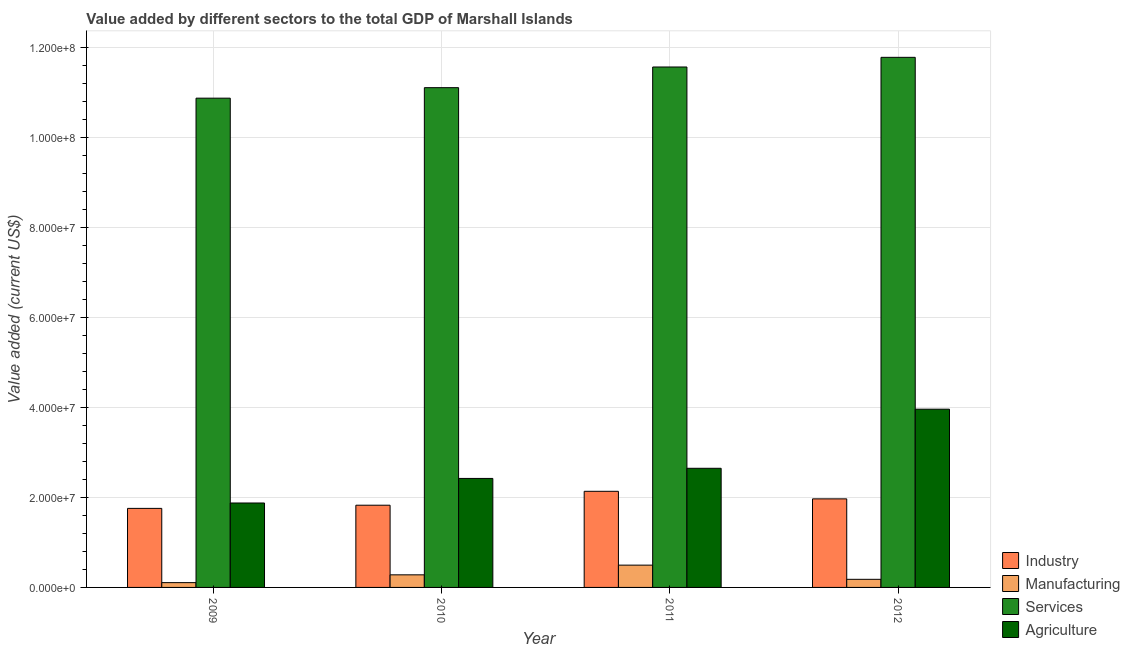Are the number of bars per tick equal to the number of legend labels?
Make the answer very short. Yes. Are the number of bars on each tick of the X-axis equal?
Provide a succinct answer. Yes. How many bars are there on the 4th tick from the left?
Make the answer very short. 4. What is the label of the 4th group of bars from the left?
Your answer should be compact. 2012. What is the value added by services sector in 2012?
Your answer should be very brief. 1.18e+08. Across all years, what is the maximum value added by agricultural sector?
Ensure brevity in your answer.  3.96e+07. Across all years, what is the minimum value added by manufacturing sector?
Give a very brief answer. 1.06e+06. In which year was the value added by manufacturing sector maximum?
Ensure brevity in your answer.  2011. What is the total value added by industrial sector in the graph?
Your answer should be compact. 7.68e+07. What is the difference between the value added by industrial sector in 2010 and that in 2011?
Offer a terse response. -3.09e+06. What is the difference between the value added by agricultural sector in 2009 and the value added by services sector in 2012?
Keep it short and to the point. -2.08e+07. What is the average value added by services sector per year?
Your response must be concise. 1.13e+08. In the year 2009, what is the difference between the value added by manufacturing sector and value added by industrial sector?
Your answer should be very brief. 0. In how many years, is the value added by agricultural sector greater than 64000000 US$?
Keep it short and to the point. 0. What is the ratio of the value added by services sector in 2010 to that in 2012?
Ensure brevity in your answer.  0.94. What is the difference between the highest and the second highest value added by industrial sector?
Provide a succinct answer. 1.68e+06. What is the difference between the highest and the lowest value added by manufacturing sector?
Your response must be concise. 3.89e+06. In how many years, is the value added by industrial sector greater than the average value added by industrial sector taken over all years?
Make the answer very short. 2. What does the 2nd bar from the left in 2012 represents?
Provide a short and direct response. Manufacturing. What does the 2nd bar from the right in 2011 represents?
Provide a short and direct response. Services. How many years are there in the graph?
Your answer should be very brief. 4. Does the graph contain grids?
Your answer should be very brief. Yes. How many legend labels are there?
Provide a short and direct response. 4. What is the title of the graph?
Provide a short and direct response. Value added by different sectors to the total GDP of Marshall Islands. What is the label or title of the Y-axis?
Your response must be concise. Value added (current US$). What is the Value added (current US$) in Industry in 2009?
Offer a very short reply. 1.76e+07. What is the Value added (current US$) in Manufacturing in 2009?
Your answer should be very brief. 1.06e+06. What is the Value added (current US$) of Services in 2009?
Provide a short and direct response. 1.09e+08. What is the Value added (current US$) of Agriculture in 2009?
Ensure brevity in your answer.  1.87e+07. What is the Value added (current US$) in Industry in 2010?
Offer a very short reply. 1.83e+07. What is the Value added (current US$) of Manufacturing in 2010?
Provide a short and direct response. 2.80e+06. What is the Value added (current US$) in Services in 2010?
Ensure brevity in your answer.  1.11e+08. What is the Value added (current US$) of Agriculture in 2010?
Your answer should be compact. 2.42e+07. What is the Value added (current US$) in Industry in 2011?
Offer a very short reply. 2.13e+07. What is the Value added (current US$) of Manufacturing in 2011?
Offer a terse response. 4.95e+06. What is the Value added (current US$) of Services in 2011?
Provide a short and direct response. 1.16e+08. What is the Value added (current US$) in Agriculture in 2011?
Make the answer very short. 2.65e+07. What is the Value added (current US$) in Industry in 2012?
Offer a very short reply. 1.97e+07. What is the Value added (current US$) of Manufacturing in 2012?
Your answer should be very brief. 1.80e+06. What is the Value added (current US$) of Services in 2012?
Provide a short and direct response. 1.18e+08. What is the Value added (current US$) of Agriculture in 2012?
Make the answer very short. 3.96e+07. Across all years, what is the maximum Value added (current US$) of Industry?
Provide a short and direct response. 2.13e+07. Across all years, what is the maximum Value added (current US$) in Manufacturing?
Offer a terse response. 4.95e+06. Across all years, what is the maximum Value added (current US$) in Services?
Your answer should be compact. 1.18e+08. Across all years, what is the maximum Value added (current US$) in Agriculture?
Offer a terse response. 3.96e+07. Across all years, what is the minimum Value added (current US$) of Industry?
Ensure brevity in your answer.  1.76e+07. Across all years, what is the minimum Value added (current US$) in Manufacturing?
Your response must be concise. 1.06e+06. Across all years, what is the minimum Value added (current US$) in Services?
Your answer should be compact. 1.09e+08. Across all years, what is the minimum Value added (current US$) in Agriculture?
Your answer should be compact. 1.87e+07. What is the total Value added (current US$) of Industry in the graph?
Your answer should be very brief. 7.68e+07. What is the total Value added (current US$) in Manufacturing in the graph?
Your answer should be very brief. 1.06e+07. What is the total Value added (current US$) of Services in the graph?
Give a very brief answer. 4.53e+08. What is the total Value added (current US$) in Agriculture in the graph?
Keep it short and to the point. 1.09e+08. What is the difference between the Value added (current US$) in Industry in 2009 and that in 2010?
Offer a very short reply. -7.02e+05. What is the difference between the Value added (current US$) in Manufacturing in 2009 and that in 2010?
Keep it short and to the point. -1.73e+06. What is the difference between the Value added (current US$) of Services in 2009 and that in 2010?
Your response must be concise. -2.33e+06. What is the difference between the Value added (current US$) of Agriculture in 2009 and that in 2010?
Your answer should be very brief. -5.46e+06. What is the difference between the Value added (current US$) in Industry in 2009 and that in 2011?
Ensure brevity in your answer.  -3.79e+06. What is the difference between the Value added (current US$) in Manufacturing in 2009 and that in 2011?
Offer a terse response. -3.89e+06. What is the difference between the Value added (current US$) of Services in 2009 and that in 2011?
Your response must be concise. -6.92e+06. What is the difference between the Value added (current US$) of Agriculture in 2009 and that in 2011?
Ensure brevity in your answer.  -7.71e+06. What is the difference between the Value added (current US$) of Industry in 2009 and that in 2012?
Offer a terse response. -2.11e+06. What is the difference between the Value added (current US$) of Manufacturing in 2009 and that in 2012?
Offer a very short reply. -7.34e+05. What is the difference between the Value added (current US$) in Services in 2009 and that in 2012?
Make the answer very short. -9.07e+06. What is the difference between the Value added (current US$) in Agriculture in 2009 and that in 2012?
Offer a very short reply. -2.08e+07. What is the difference between the Value added (current US$) in Industry in 2010 and that in 2011?
Offer a terse response. -3.09e+06. What is the difference between the Value added (current US$) of Manufacturing in 2010 and that in 2011?
Offer a very short reply. -2.16e+06. What is the difference between the Value added (current US$) in Services in 2010 and that in 2011?
Give a very brief answer. -4.59e+06. What is the difference between the Value added (current US$) of Agriculture in 2010 and that in 2011?
Your answer should be very brief. -2.25e+06. What is the difference between the Value added (current US$) in Industry in 2010 and that in 2012?
Offer a very short reply. -1.41e+06. What is the difference between the Value added (current US$) in Manufacturing in 2010 and that in 2012?
Your response must be concise. 9.96e+05. What is the difference between the Value added (current US$) of Services in 2010 and that in 2012?
Your response must be concise. -6.74e+06. What is the difference between the Value added (current US$) of Agriculture in 2010 and that in 2012?
Make the answer very short. -1.54e+07. What is the difference between the Value added (current US$) of Industry in 2011 and that in 2012?
Your answer should be very brief. 1.68e+06. What is the difference between the Value added (current US$) of Manufacturing in 2011 and that in 2012?
Your response must be concise. 3.15e+06. What is the difference between the Value added (current US$) of Services in 2011 and that in 2012?
Keep it short and to the point. -2.14e+06. What is the difference between the Value added (current US$) of Agriculture in 2011 and that in 2012?
Offer a terse response. -1.31e+07. What is the difference between the Value added (current US$) in Industry in 2009 and the Value added (current US$) in Manufacturing in 2010?
Make the answer very short. 1.48e+07. What is the difference between the Value added (current US$) in Industry in 2009 and the Value added (current US$) in Services in 2010?
Provide a short and direct response. -9.34e+07. What is the difference between the Value added (current US$) of Industry in 2009 and the Value added (current US$) of Agriculture in 2010?
Offer a terse response. -6.65e+06. What is the difference between the Value added (current US$) of Manufacturing in 2009 and the Value added (current US$) of Services in 2010?
Ensure brevity in your answer.  -1.10e+08. What is the difference between the Value added (current US$) in Manufacturing in 2009 and the Value added (current US$) in Agriculture in 2010?
Your answer should be very brief. -2.31e+07. What is the difference between the Value added (current US$) in Services in 2009 and the Value added (current US$) in Agriculture in 2010?
Ensure brevity in your answer.  8.44e+07. What is the difference between the Value added (current US$) of Industry in 2009 and the Value added (current US$) of Manufacturing in 2011?
Provide a short and direct response. 1.26e+07. What is the difference between the Value added (current US$) of Industry in 2009 and the Value added (current US$) of Services in 2011?
Your answer should be very brief. -9.80e+07. What is the difference between the Value added (current US$) of Industry in 2009 and the Value added (current US$) of Agriculture in 2011?
Your response must be concise. -8.90e+06. What is the difference between the Value added (current US$) in Manufacturing in 2009 and the Value added (current US$) in Services in 2011?
Give a very brief answer. -1.15e+08. What is the difference between the Value added (current US$) of Manufacturing in 2009 and the Value added (current US$) of Agriculture in 2011?
Your response must be concise. -2.54e+07. What is the difference between the Value added (current US$) in Services in 2009 and the Value added (current US$) in Agriculture in 2011?
Give a very brief answer. 8.22e+07. What is the difference between the Value added (current US$) of Industry in 2009 and the Value added (current US$) of Manufacturing in 2012?
Your answer should be very brief. 1.58e+07. What is the difference between the Value added (current US$) of Industry in 2009 and the Value added (current US$) of Services in 2012?
Keep it short and to the point. -1.00e+08. What is the difference between the Value added (current US$) of Industry in 2009 and the Value added (current US$) of Agriculture in 2012?
Provide a succinct answer. -2.20e+07. What is the difference between the Value added (current US$) in Manufacturing in 2009 and the Value added (current US$) in Services in 2012?
Your response must be concise. -1.17e+08. What is the difference between the Value added (current US$) of Manufacturing in 2009 and the Value added (current US$) of Agriculture in 2012?
Keep it short and to the point. -3.85e+07. What is the difference between the Value added (current US$) in Services in 2009 and the Value added (current US$) in Agriculture in 2012?
Offer a very short reply. 6.91e+07. What is the difference between the Value added (current US$) in Industry in 2010 and the Value added (current US$) in Manufacturing in 2011?
Your answer should be very brief. 1.33e+07. What is the difference between the Value added (current US$) in Industry in 2010 and the Value added (current US$) in Services in 2011?
Ensure brevity in your answer.  -9.73e+07. What is the difference between the Value added (current US$) of Industry in 2010 and the Value added (current US$) of Agriculture in 2011?
Keep it short and to the point. -8.20e+06. What is the difference between the Value added (current US$) of Manufacturing in 2010 and the Value added (current US$) of Services in 2011?
Offer a terse response. -1.13e+08. What is the difference between the Value added (current US$) of Manufacturing in 2010 and the Value added (current US$) of Agriculture in 2011?
Offer a terse response. -2.37e+07. What is the difference between the Value added (current US$) in Services in 2010 and the Value added (current US$) in Agriculture in 2011?
Your response must be concise. 8.45e+07. What is the difference between the Value added (current US$) in Industry in 2010 and the Value added (current US$) in Manufacturing in 2012?
Offer a very short reply. 1.65e+07. What is the difference between the Value added (current US$) of Industry in 2010 and the Value added (current US$) of Services in 2012?
Offer a terse response. -9.95e+07. What is the difference between the Value added (current US$) in Industry in 2010 and the Value added (current US$) in Agriculture in 2012?
Give a very brief answer. -2.13e+07. What is the difference between the Value added (current US$) in Manufacturing in 2010 and the Value added (current US$) in Services in 2012?
Provide a succinct answer. -1.15e+08. What is the difference between the Value added (current US$) of Manufacturing in 2010 and the Value added (current US$) of Agriculture in 2012?
Your response must be concise. -3.68e+07. What is the difference between the Value added (current US$) in Services in 2010 and the Value added (current US$) in Agriculture in 2012?
Ensure brevity in your answer.  7.14e+07. What is the difference between the Value added (current US$) of Industry in 2011 and the Value added (current US$) of Manufacturing in 2012?
Your answer should be compact. 1.95e+07. What is the difference between the Value added (current US$) of Industry in 2011 and the Value added (current US$) of Services in 2012?
Offer a very short reply. -9.64e+07. What is the difference between the Value added (current US$) of Industry in 2011 and the Value added (current US$) of Agriculture in 2012?
Make the answer very short. -1.82e+07. What is the difference between the Value added (current US$) in Manufacturing in 2011 and the Value added (current US$) in Services in 2012?
Your answer should be compact. -1.13e+08. What is the difference between the Value added (current US$) in Manufacturing in 2011 and the Value added (current US$) in Agriculture in 2012?
Make the answer very short. -3.46e+07. What is the difference between the Value added (current US$) in Services in 2011 and the Value added (current US$) in Agriculture in 2012?
Provide a short and direct response. 7.60e+07. What is the average Value added (current US$) of Industry per year?
Your response must be concise. 1.92e+07. What is the average Value added (current US$) of Manufacturing per year?
Your answer should be compact. 2.65e+06. What is the average Value added (current US$) of Services per year?
Make the answer very short. 1.13e+08. What is the average Value added (current US$) of Agriculture per year?
Your answer should be compact. 2.72e+07. In the year 2009, what is the difference between the Value added (current US$) in Industry and Value added (current US$) in Manufacturing?
Give a very brief answer. 1.65e+07. In the year 2009, what is the difference between the Value added (current US$) in Industry and Value added (current US$) in Services?
Ensure brevity in your answer.  -9.11e+07. In the year 2009, what is the difference between the Value added (current US$) in Industry and Value added (current US$) in Agriculture?
Offer a very short reply. -1.20e+06. In the year 2009, what is the difference between the Value added (current US$) of Manufacturing and Value added (current US$) of Services?
Ensure brevity in your answer.  -1.08e+08. In the year 2009, what is the difference between the Value added (current US$) in Manufacturing and Value added (current US$) in Agriculture?
Your answer should be compact. -1.77e+07. In the year 2009, what is the difference between the Value added (current US$) of Services and Value added (current US$) of Agriculture?
Make the answer very short. 8.99e+07. In the year 2010, what is the difference between the Value added (current US$) in Industry and Value added (current US$) in Manufacturing?
Make the answer very short. 1.55e+07. In the year 2010, what is the difference between the Value added (current US$) in Industry and Value added (current US$) in Services?
Make the answer very short. -9.27e+07. In the year 2010, what is the difference between the Value added (current US$) of Industry and Value added (current US$) of Agriculture?
Your answer should be very brief. -5.95e+06. In the year 2010, what is the difference between the Value added (current US$) in Manufacturing and Value added (current US$) in Services?
Give a very brief answer. -1.08e+08. In the year 2010, what is the difference between the Value added (current US$) in Manufacturing and Value added (current US$) in Agriculture?
Offer a very short reply. -2.14e+07. In the year 2010, what is the difference between the Value added (current US$) of Services and Value added (current US$) of Agriculture?
Your response must be concise. 8.68e+07. In the year 2011, what is the difference between the Value added (current US$) of Industry and Value added (current US$) of Manufacturing?
Provide a succinct answer. 1.64e+07. In the year 2011, what is the difference between the Value added (current US$) in Industry and Value added (current US$) in Services?
Your answer should be very brief. -9.42e+07. In the year 2011, what is the difference between the Value added (current US$) of Industry and Value added (current US$) of Agriculture?
Provide a short and direct response. -5.11e+06. In the year 2011, what is the difference between the Value added (current US$) of Manufacturing and Value added (current US$) of Services?
Give a very brief answer. -1.11e+08. In the year 2011, what is the difference between the Value added (current US$) in Manufacturing and Value added (current US$) in Agriculture?
Provide a short and direct response. -2.15e+07. In the year 2011, what is the difference between the Value added (current US$) of Services and Value added (current US$) of Agriculture?
Offer a terse response. 8.91e+07. In the year 2012, what is the difference between the Value added (current US$) in Industry and Value added (current US$) in Manufacturing?
Keep it short and to the point. 1.79e+07. In the year 2012, what is the difference between the Value added (current US$) of Industry and Value added (current US$) of Services?
Provide a short and direct response. -9.80e+07. In the year 2012, what is the difference between the Value added (current US$) in Industry and Value added (current US$) in Agriculture?
Give a very brief answer. -1.99e+07. In the year 2012, what is the difference between the Value added (current US$) of Manufacturing and Value added (current US$) of Services?
Ensure brevity in your answer.  -1.16e+08. In the year 2012, what is the difference between the Value added (current US$) in Manufacturing and Value added (current US$) in Agriculture?
Ensure brevity in your answer.  -3.78e+07. In the year 2012, what is the difference between the Value added (current US$) in Services and Value added (current US$) in Agriculture?
Keep it short and to the point. 7.81e+07. What is the ratio of the Value added (current US$) of Industry in 2009 to that in 2010?
Your answer should be compact. 0.96. What is the ratio of the Value added (current US$) of Manufacturing in 2009 to that in 2010?
Make the answer very short. 0.38. What is the ratio of the Value added (current US$) of Agriculture in 2009 to that in 2010?
Give a very brief answer. 0.77. What is the ratio of the Value added (current US$) of Industry in 2009 to that in 2011?
Give a very brief answer. 0.82. What is the ratio of the Value added (current US$) in Manufacturing in 2009 to that in 2011?
Your answer should be compact. 0.21. What is the ratio of the Value added (current US$) in Services in 2009 to that in 2011?
Offer a terse response. 0.94. What is the ratio of the Value added (current US$) in Agriculture in 2009 to that in 2011?
Offer a terse response. 0.71. What is the ratio of the Value added (current US$) in Industry in 2009 to that in 2012?
Make the answer very short. 0.89. What is the ratio of the Value added (current US$) in Manufacturing in 2009 to that in 2012?
Your answer should be very brief. 0.59. What is the ratio of the Value added (current US$) in Services in 2009 to that in 2012?
Ensure brevity in your answer.  0.92. What is the ratio of the Value added (current US$) in Agriculture in 2009 to that in 2012?
Your answer should be compact. 0.47. What is the ratio of the Value added (current US$) in Industry in 2010 to that in 2011?
Make the answer very short. 0.86. What is the ratio of the Value added (current US$) in Manufacturing in 2010 to that in 2011?
Offer a very short reply. 0.56. What is the ratio of the Value added (current US$) in Services in 2010 to that in 2011?
Offer a terse response. 0.96. What is the ratio of the Value added (current US$) of Agriculture in 2010 to that in 2011?
Your answer should be compact. 0.91. What is the ratio of the Value added (current US$) in Industry in 2010 to that in 2012?
Offer a terse response. 0.93. What is the ratio of the Value added (current US$) in Manufacturing in 2010 to that in 2012?
Make the answer very short. 1.55. What is the ratio of the Value added (current US$) of Services in 2010 to that in 2012?
Your answer should be very brief. 0.94. What is the ratio of the Value added (current US$) in Agriculture in 2010 to that in 2012?
Ensure brevity in your answer.  0.61. What is the ratio of the Value added (current US$) of Industry in 2011 to that in 2012?
Provide a succinct answer. 1.09. What is the ratio of the Value added (current US$) in Manufacturing in 2011 to that in 2012?
Offer a terse response. 2.75. What is the ratio of the Value added (current US$) in Services in 2011 to that in 2012?
Your answer should be very brief. 0.98. What is the ratio of the Value added (current US$) of Agriculture in 2011 to that in 2012?
Ensure brevity in your answer.  0.67. What is the difference between the highest and the second highest Value added (current US$) in Industry?
Your answer should be compact. 1.68e+06. What is the difference between the highest and the second highest Value added (current US$) in Manufacturing?
Provide a short and direct response. 2.16e+06. What is the difference between the highest and the second highest Value added (current US$) of Services?
Your answer should be very brief. 2.14e+06. What is the difference between the highest and the second highest Value added (current US$) in Agriculture?
Give a very brief answer. 1.31e+07. What is the difference between the highest and the lowest Value added (current US$) in Industry?
Your answer should be very brief. 3.79e+06. What is the difference between the highest and the lowest Value added (current US$) of Manufacturing?
Your response must be concise. 3.89e+06. What is the difference between the highest and the lowest Value added (current US$) of Services?
Offer a very short reply. 9.07e+06. What is the difference between the highest and the lowest Value added (current US$) of Agriculture?
Offer a very short reply. 2.08e+07. 